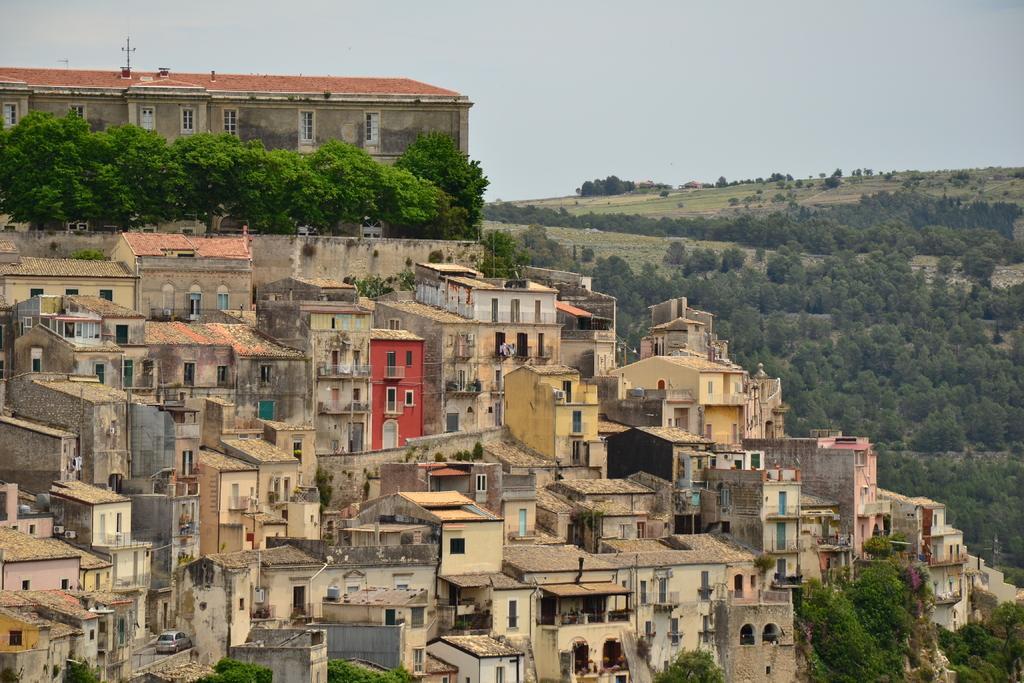Describe this image in one or two sentences. This picture is of outside the city. On the right we can see there are many number of trees and the ground covered with a green grass. In the center there are many number of buildings and we can see a car and in the background can see the pole, windows, trees and the sky. 